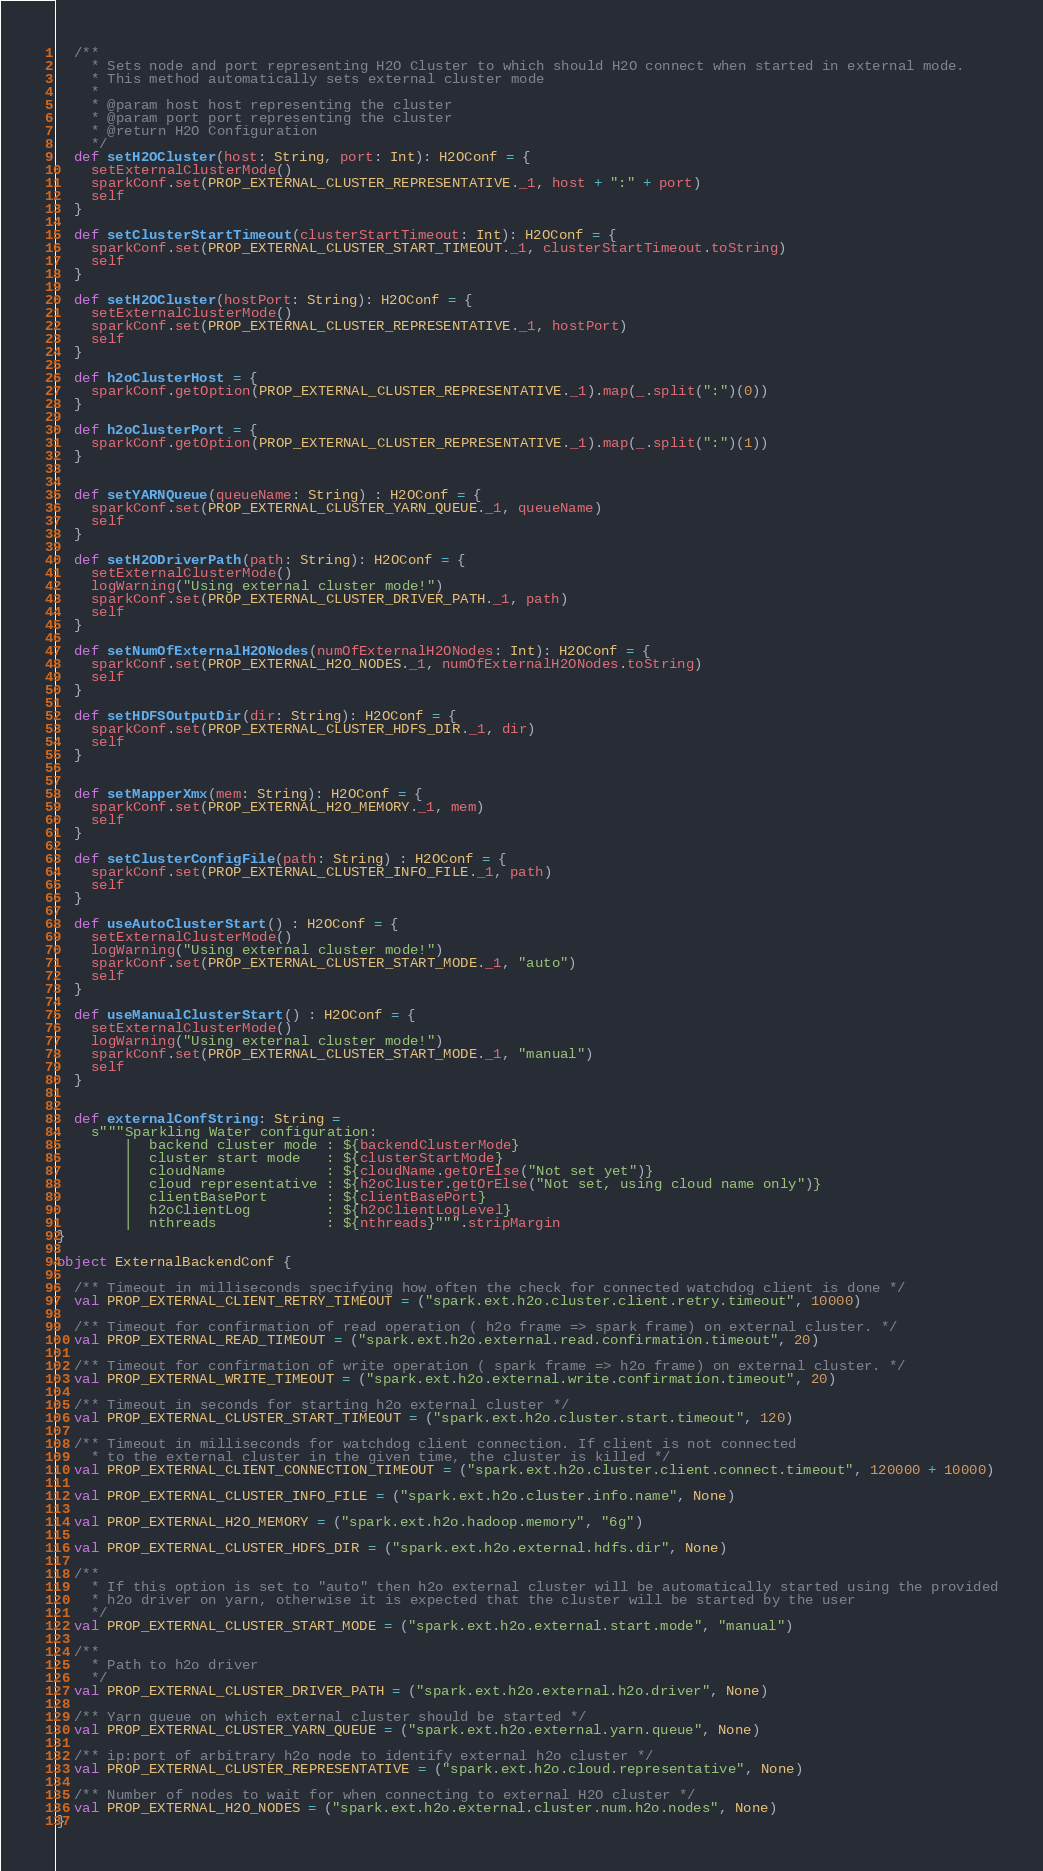Convert code to text. <code><loc_0><loc_0><loc_500><loc_500><_Scala_>
  /**
    * Sets node and port representing H2O Cluster to which should H2O connect when started in external mode.
    * This method automatically sets external cluster mode
    *
    * @param host host representing the cluster
    * @param port port representing the cluster
    * @return H2O Configuration
    */
  def setH2OCluster(host: String, port: Int): H2OConf = {
    setExternalClusterMode()
    sparkConf.set(PROP_EXTERNAL_CLUSTER_REPRESENTATIVE._1, host + ":" + port)
    self
  }

  def setClusterStartTimeout(clusterStartTimeout: Int): H2OConf = {
    sparkConf.set(PROP_EXTERNAL_CLUSTER_START_TIMEOUT._1, clusterStartTimeout.toString)
    self
  }

  def setH2OCluster(hostPort: String): H2OConf = {
    setExternalClusterMode()
    sparkConf.set(PROP_EXTERNAL_CLUSTER_REPRESENTATIVE._1, hostPort)
    self
  }

  def h2oClusterHost = {
    sparkConf.getOption(PROP_EXTERNAL_CLUSTER_REPRESENTATIVE._1).map(_.split(":")(0))
  }

  def h2oClusterPort = {
    sparkConf.getOption(PROP_EXTERNAL_CLUSTER_REPRESENTATIVE._1).map(_.split(":")(1))
  }


  def setYARNQueue(queueName: String) : H2OConf = {
    sparkConf.set(PROP_EXTERNAL_CLUSTER_YARN_QUEUE._1, queueName)
    self
  }

  def setH2ODriverPath(path: String): H2OConf = {
    setExternalClusterMode()
    logWarning("Using external cluster mode!")
    sparkConf.set(PROP_EXTERNAL_CLUSTER_DRIVER_PATH._1, path)
    self
  }

  def setNumOfExternalH2ONodes(numOfExternalH2ONodes: Int): H2OConf = {
    sparkConf.set(PROP_EXTERNAL_H2O_NODES._1, numOfExternalH2ONodes.toString)
    self
  }

  def setHDFSOutputDir(dir: String): H2OConf = {
    sparkConf.set(PROP_EXTERNAL_CLUSTER_HDFS_DIR._1, dir)
    self
  }


  def setMapperXmx(mem: String): H2OConf = {
    sparkConf.set(PROP_EXTERNAL_H2O_MEMORY._1, mem)
    self
  }

  def setClusterConfigFile(path: String) : H2OConf = {
    sparkConf.set(PROP_EXTERNAL_CLUSTER_INFO_FILE._1, path)
    self
  }

  def useAutoClusterStart() : H2OConf = {
    setExternalClusterMode()
    logWarning("Using external cluster mode!")
    sparkConf.set(PROP_EXTERNAL_CLUSTER_START_MODE._1, "auto")
    self
  }

  def useManualClusterStart() : H2OConf = {
    setExternalClusterMode()
    logWarning("Using external cluster mode!")
    sparkConf.set(PROP_EXTERNAL_CLUSTER_START_MODE._1, "manual")
    self
  }


  def externalConfString: String =
    s"""Sparkling Water configuration:
        |  backend cluster mode : ${backendClusterMode}
        |  cluster start mode   : ${clusterStartMode}
        |  cloudName            : ${cloudName.getOrElse("Not set yet")}
        |  cloud representative : ${h2oCluster.getOrElse("Not set, using cloud name only")}
        |  clientBasePort       : ${clientBasePort}
        |  h2oClientLog         : ${h2oClientLogLevel}
        |  nthreads             : ${nthreads}""".stripMargin
}

object ExternalBackendConf {

  /** Timeout in milliseconds specifying how often the check for connected watchdog client is done */
  val PROP_EXTERNAL_CLIENT_RETRY_TIMEOUT = ("spark.ext.h2o.cluster.client.retry.timeout", 10000)

  /** Timeout for confirmation of read operation ( h2o frame => spark frame) on external cluster. */
  val PROP_EXTERNAL_READ_TIMEOUT = ("spark.ext.h2o.external.read.confirmation.timeout", 20)

  /** Timeout for confirmation of write operation ( spark frame => h2o frame) on external cluster. */
  val PROP_EXTERNAL_WRITE_TIMEOUT = ("spark.ext.h2o.external.write.confirmation.timeout", 20)

  /** Timeout in seconds for starting h2o external cluster */
  val PROP_EXTERNAL_CLUSTER_START_TIMEOUT = ("spark.ext.h2o.cluster.start.timeout", 120)

  /** Timeout in milliseconds for watchdog client connection. If client is not connected
    * to the external cluster in the given time, the cluster is killed */
  val PROP_EXTERNAL_CLIENT_CONNECTION_TIMEOUT = ("spark.ext.h2o.cluster.client.connect.timeout", 120000 + 10000)

  val PROP_EXTERNAL_CLUSTER_INFO_FILE = ("spark.ext.h2o.cluster.info.name", None)

  val PROP_EXTERNAL_H2O_MEMORY = ("spark.ext.h2o.hadoop.memory", "6g")

  val PROP_EXTERNAL_CLUSTER_HDFS_DIR = ("spark.ext.h2o.external.hdfs.dir", None)

  /**
    * If this option is set to "auto" then h2o external cluster will be automatically started using the provided
    * h2o driver on yarn, otherwise it is expected that the cluster will be started by the user
    */
  val PROP_EXTERNAL_CLUSTER_START_MODE = ("spark.ext.h2o.external.start.mode", "manual")

  /**
    * Path to h2o driver
    */
  val PROP_EXTERNAL_CLUSTER_DRIVER_PATH = ("spark.ext.h2o.external.h2o.driver", None)

  /** Yarn queue on which external cluster should be started */
  val PROP_EXTERNAL_CLUSTER_YARN_QUEUE = ("spark.ext.h2o.external.yarn.queue", None)

  /** ip:port of arbitrary h2o node to identify external h2o cluster */
  val PROP_EXTERNAL_CLUSTER_REPRESENTATIVE = ("spark.ext.h2o.cloud.representative", None)

  /** Number of nodes to wait for when connecting to external H2O cluster */
  val PROP_EXTERNAL_H2O_NODES = ("spark.ext.h2o.external.cluster.num.h2o.nodes", None)
}
</code> 